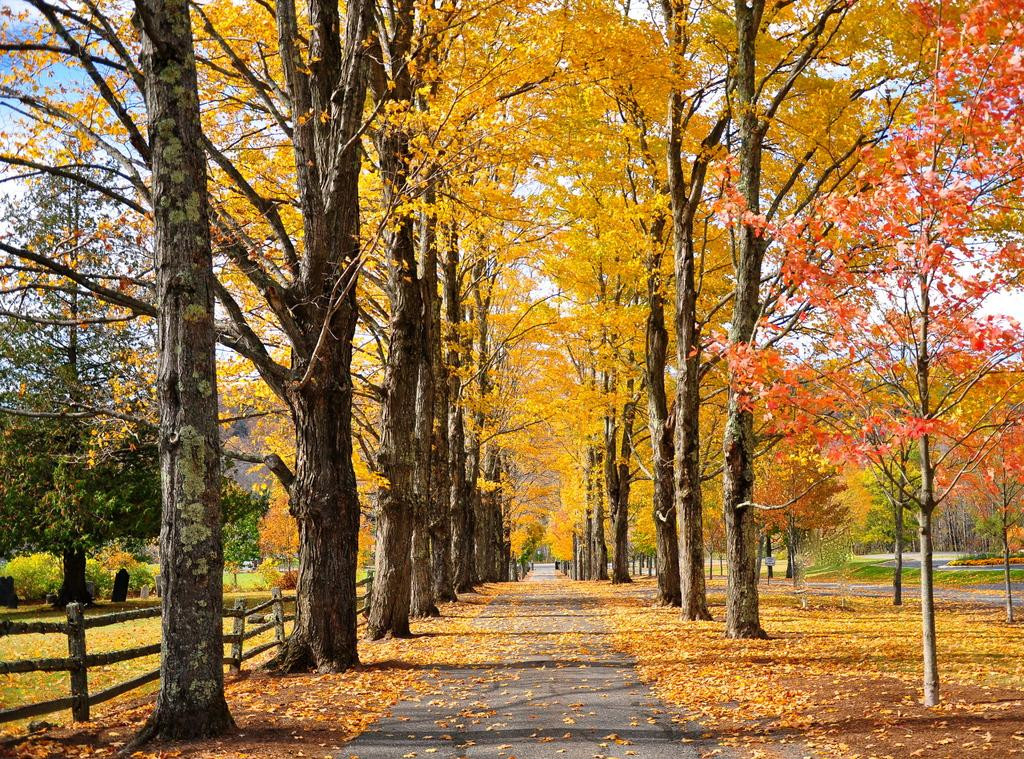What is the main feature of the image? There is a road in the image. What can be seen on the ground near the road? Dried leaves are present in the image. What type of barrier is visible in the image? There is a fence in the image. What type of vegetation is visible in the image? Grass, plants, and trees are visible in the image. What is visible in the background of the image? The sky is visible in the background of the image. How many babies are crawling on the road in the image? There are no babies present in the image; it only features a road, dried leaves, a fence, grass, plants, trees, and the sky. 